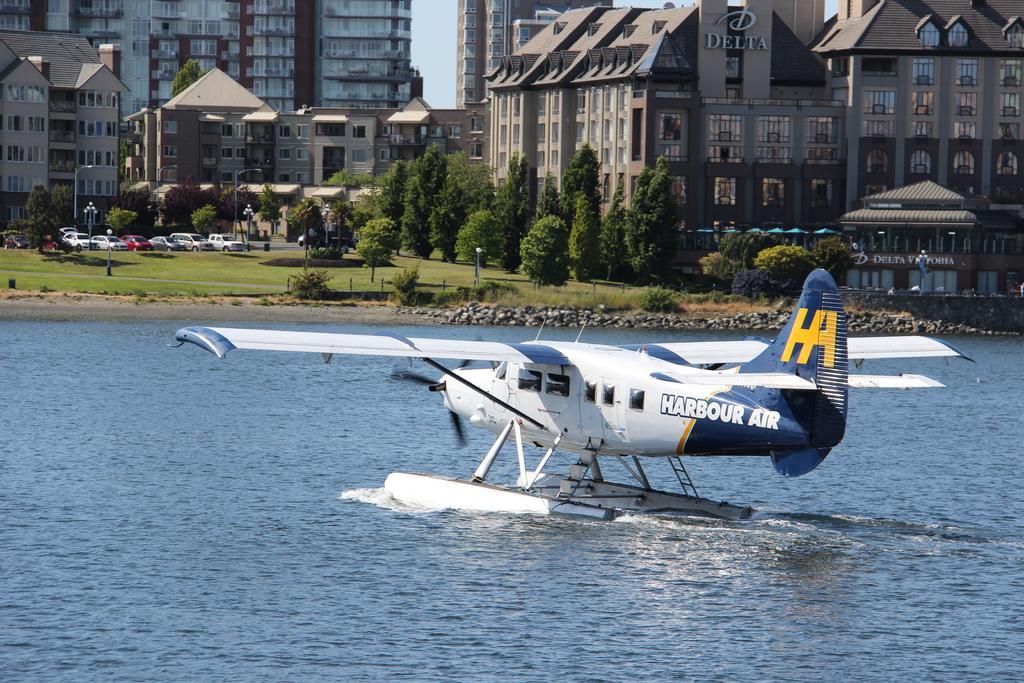Could you give a brief overview of what you see in this image? In this image, there is water, there is an aircraft which is in white and blue color landing on the water, at the background there are some green color trees and there are some buildings. 